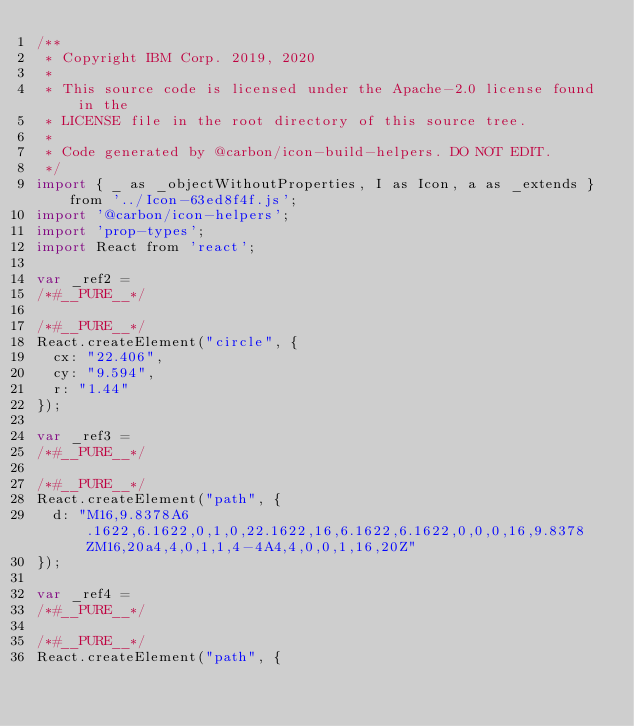Convert code to text. <code><loc_0><loc_0><loc_500><loc_500><_JavaScript_>/**
 * Copyright IBM Corp. 2019, 2020
 *
 * This source code is licensed under the Apache-2.0 license found in the
 * LICENSE file in the root directory of this source tree.
 *
 * Code generated by @carbon/icon-build-helpers. DO NOT EDIT.
 */
import { _ as _objectWithoutProperties, I as Icon, a as _extends } from '../Icon-63ed8f4f.js';
import '@carbon/icon-helpers';
import 'prop-types';
import React from 'react';

var _ref2 =
/*#__PURE__*/

/*#__PURE__*/
React.createElement("circle", {
  cx: "22.406",
  cy: "9.594",
  r: "1.44"
});

var _ref3 =
/*#__PURE__*/

/*#__PURE__*/
React.createElement("path", {
  d: "M16,9.8378A6.1622,6.1622,0,1,0,22.1622,16,6.1622,6.1622,0,0,0,16,9.8378ZM16,20a4,4,0,1,1,4-4A4,4,0,0,1,16,20Z"
});

var _ref4 =
/*#__PURE__*/

/*#__PURE__*/
React.createElement("path", {</code> 